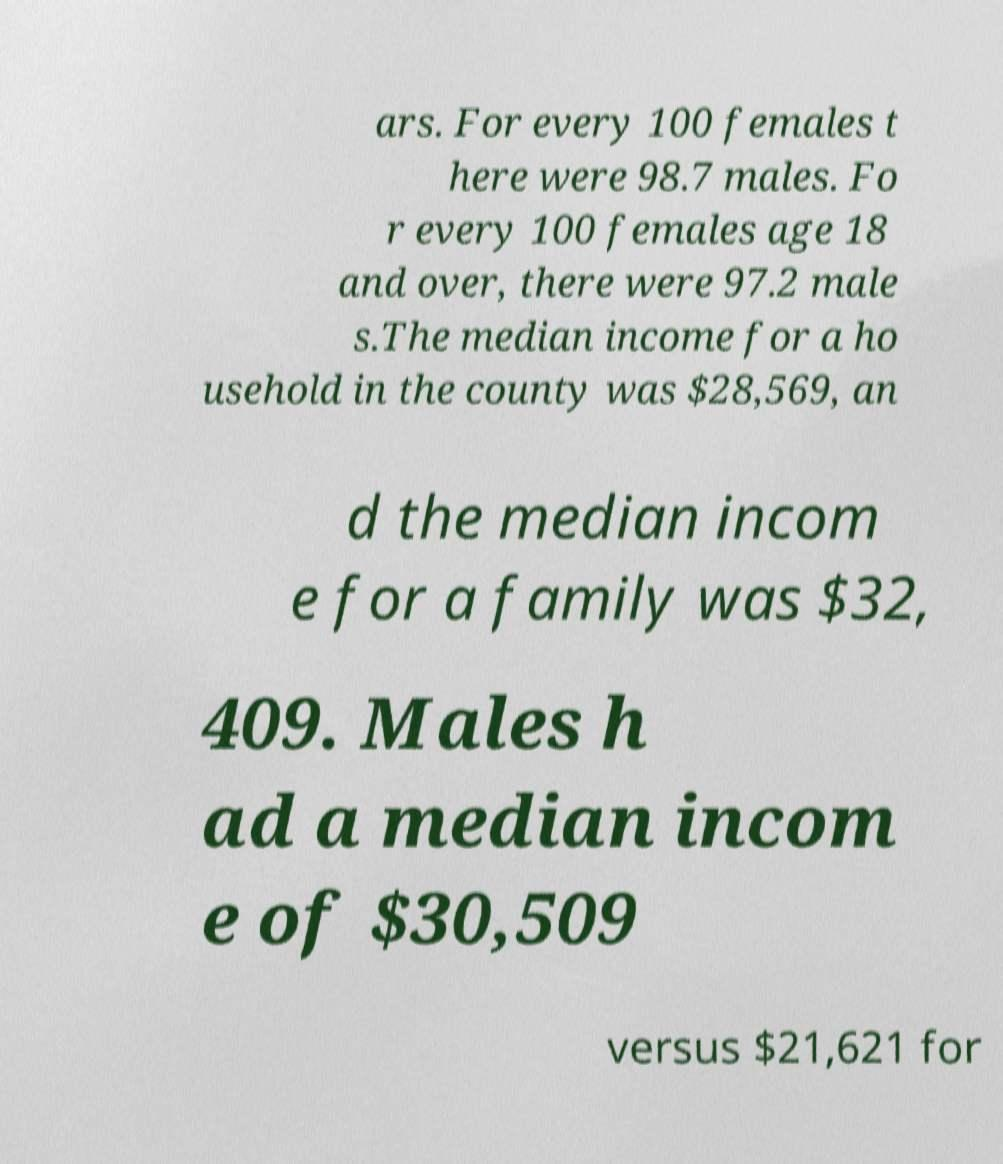Please identify and transcribe the text found in this image. ars. For every 100 females t here were 98.7 males. Fo r every 100 females age 18 and over, there were 97.2 male s.The median income for a ho usehold in the county was $28,569, an d the median incom e for a family was $32, 409. Males h ad a median incom e of $30,509 versus $21,621 for 